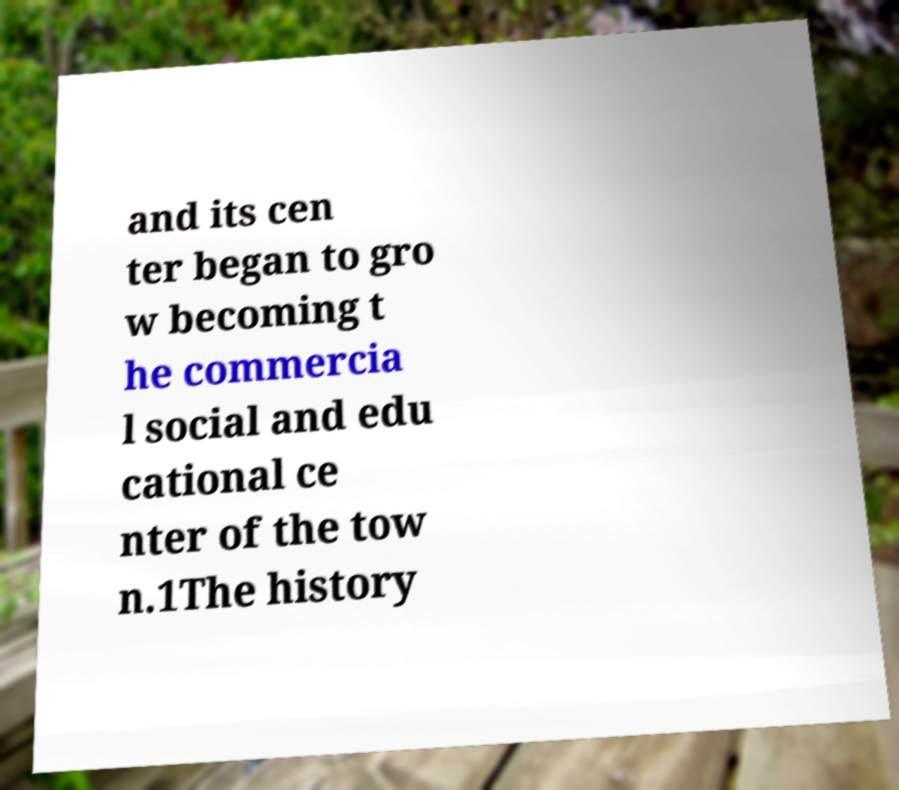Can you read and provide the text displayed in the image?This photo seems to have some interesting text. Can you extract and type it out for me? and its cen ter began to gro w becoming t he commercia l social and edu cational ce nter of the tow n.1The history 